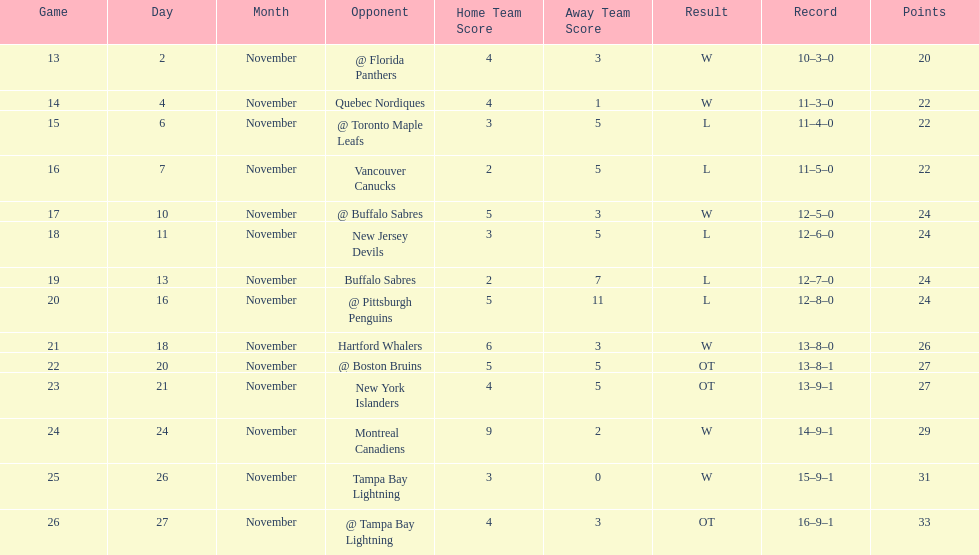Were the new jersey devils in last place according to the chart? No. Would you be able to parse every entry in this table? {'header': ['Game', 'Day', 'Month', 'Opponent', 'Home Team Score', 'Away Team Score', 'Result', 'Record', 'Points'], 'rows': [['13', '2', 'November', '@ Florida Panthers', '4', '3', 'W', '10–3–0', '20'], ['14', '4', 'November', 'Quebec Nordiques', '4', '1', 'W', '11–3–0', '22'], ['15', '6', 'November', '@ Toronto Maple Leafs', '3', '5', 'L', '11–4–0', '22'], ['16', '7', 'November', 'Vancouver Canucks', '2', '5', 'L', '11–5–0', '22'], ['17', '10', 'November', '@ Buffalo Sabres', '5', '3', 'W', '12–5–0', '24'], ['18', '11', 'November', 'New Jersey Devils', '3', '5', 'L', '12–6–0', '24'], ['19', '13', 'November', 'Buffalo Sabres', '2', '7', 'L', '12–7–0', '24'], ['20', '16', 'November', '@ Pittsburgh Penguins', '5', '11', 'L', '12–8–0', '24'], ['21', '18', 'November', 'Hartford Whalers', '6', '3', 'W', '13–8–0', '26'], ['22', '20', 'November', '@ Boston Bruins', '5', '5', 'OT', '13–8–1', '27'], ['23', '21', 'November', 'New York Islanders', '4', '5', 'OT', '13–9–1', '27'], ['24', '24', 'November', 'Montreal Canadiens', '9', '2', 'W', '14–9–1', '29'], ['25', '26', 'November', 'Tampa Bay Lightning', '3', '0', 'W', '15–9–1', '31'], ['26', '27', 'November', '@ Tampa Bay Lightning', '4', '3', 'OT', '16–9–1', '33']]} 